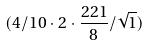Convert formula to latex. <formula><loc_0><loc_0><loc_500><loc_500>( 4 / 1 0 \cdot 2 \cdot \frac { 2 2 1 } { 8 } / \sqrt { 1 } )</formula> 